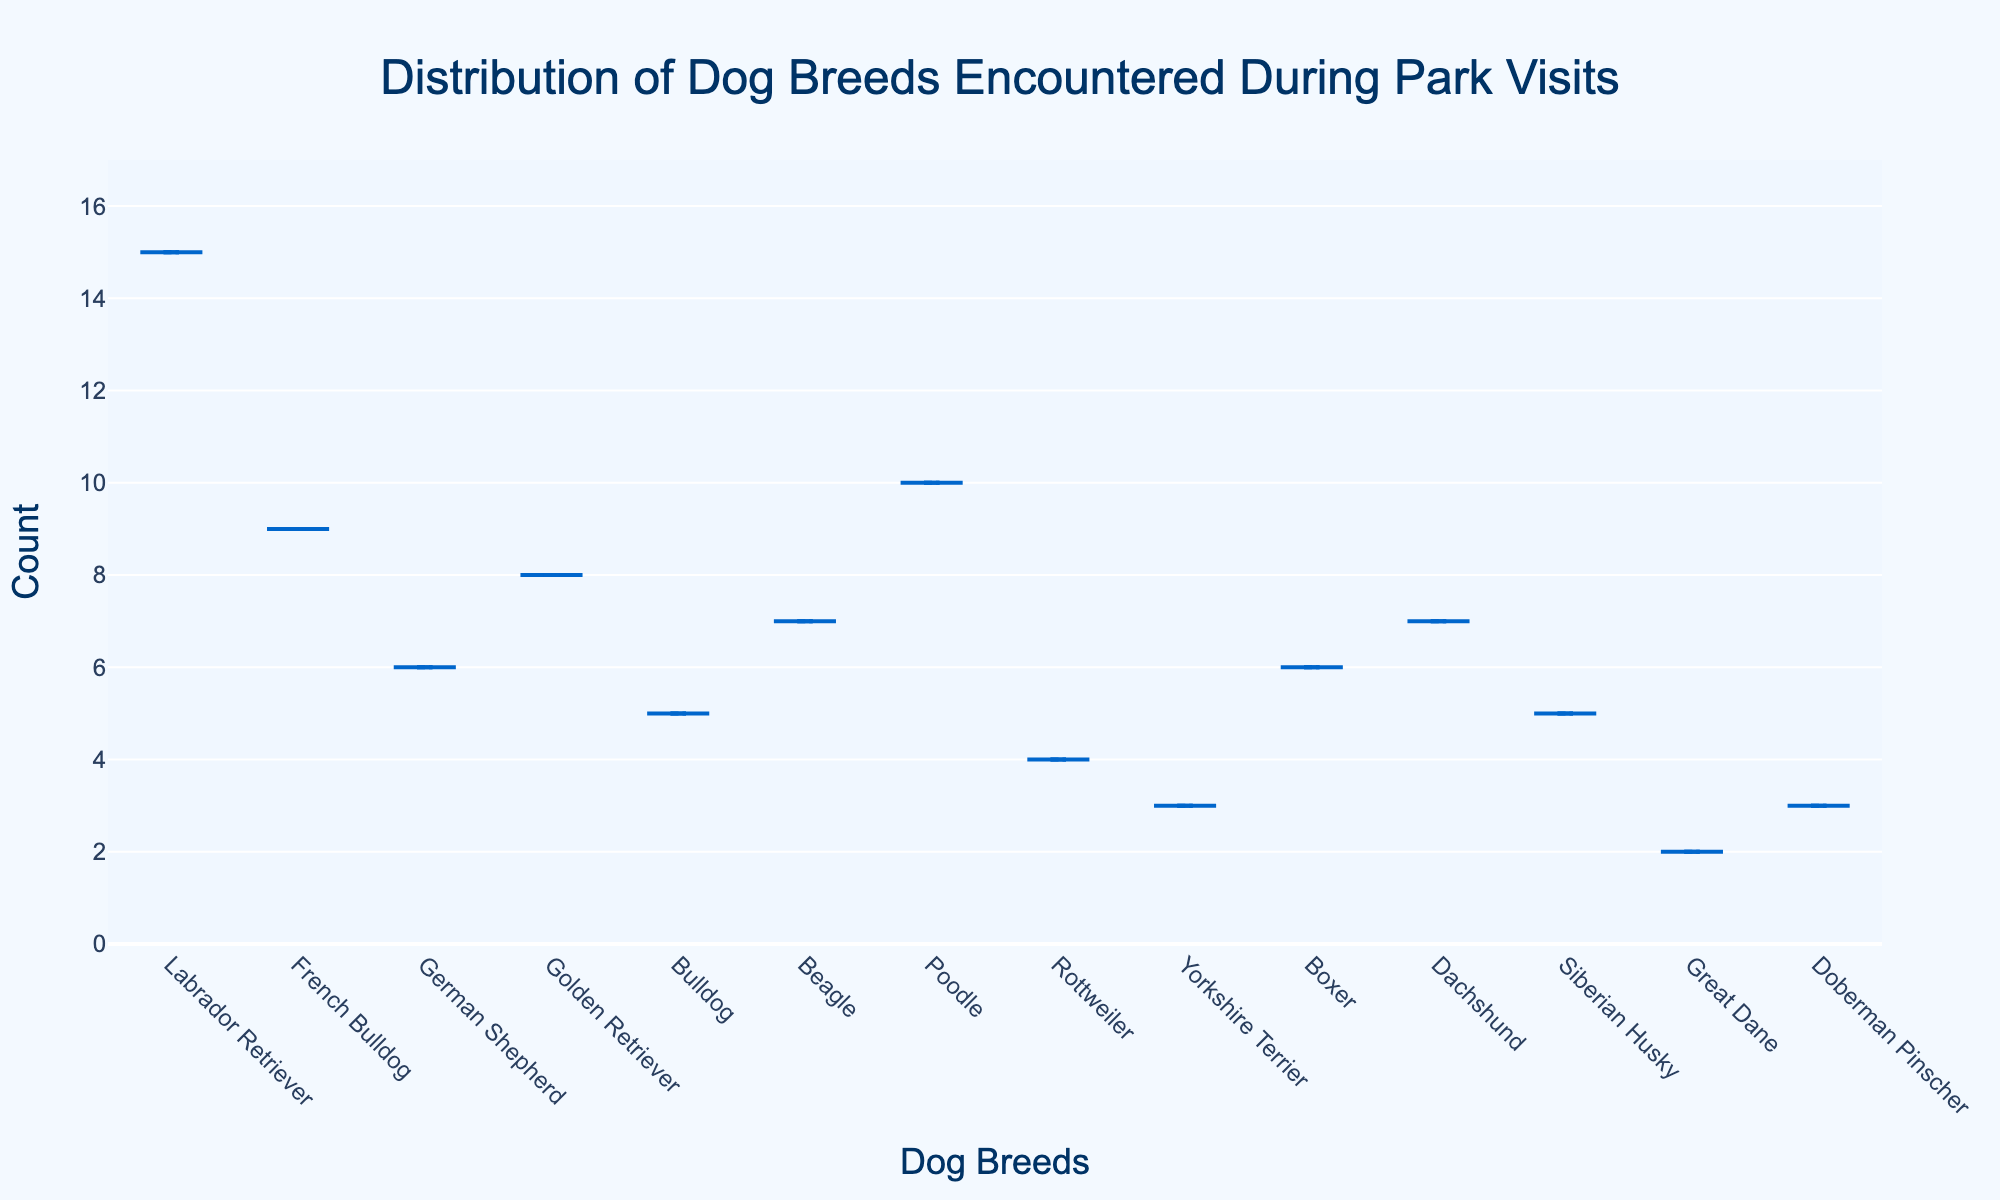What is the title of the plot? The title is positioned at the top center of the plot and provides a summary of what the plot is about.
Answer: "Distribution of Dog Breeds Encountered During Park Visits" What is the most commonly encountered dog breed during park visits? The violin plot has a box at the highest count, indicating the most commonly encountered breed, which is Labrador Retriever with 15 counts.
Answer: Labrador Retriever How many breeds have a count of 5? By visually checking the counts along the y-axis and matching them to the respective breeds, we see Bulldogs and Siberian Huskies each have a count of 5.
Answer: 2 Which breed has appeared less frequently, Great Dane or Doberman Pinscher? By comparing the height of the violins, Great Dane appears less frequently with a count of 2, while Doberman Pinscher has a count of 3.
Answer: Great Dane What is the combined count of Poodles and Boxers? Sum the counts of Poodles (10) and Boxers (6), which gives 10 + 6 = 16.
Answer: 16 How many breeds have a count higher than 7? By checking the breeds with counts greater than 7 which are Labrador Retriever (15), French Bulldog (9), Golden Retriever (8), and Poodle (10), there are four such breeds.
Answer: 4 Which breed count is closest to the median count of all breeds? Listed all counts [15, 9, 6, 8, 5, 7, 10, 4, 3, 6, 7, 5, 2, 3], sorted these as [2, 3, 3, 4, 5, 5, 6, 6, 7, 7, 8, 9, 10, 15], the median is the average of the 7th and 8th data points, (6+6)/2 = 6.
Answer: German Shepherd or Boxer (both have 6) Are there more breeds with a count below 5 or above 5? Counting the breeds below 5 (Great Dane, Doberman Pinscher, Yorkshire Terrier, Rottweiler) is 4, and those above 5 are (Labrador Retriever, French Bulldog, German Shepherd, Golden Retriever, Beagle, Poodle, Boxer, Dachshund, Siberian Husky, Bulldog) is 10.
Answer: Above 5 What is the range of the counts on the plot? The maximum count is 15 (Labrador Retriever) and the minimum count is 2 (Great Dane), therefore the range is 15 - 2 = 13.
Answer: 13 